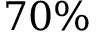Convert formula to latex. <formula><loc_0><loc_0><loc_500><loc_500>7 0 \%</formula> 